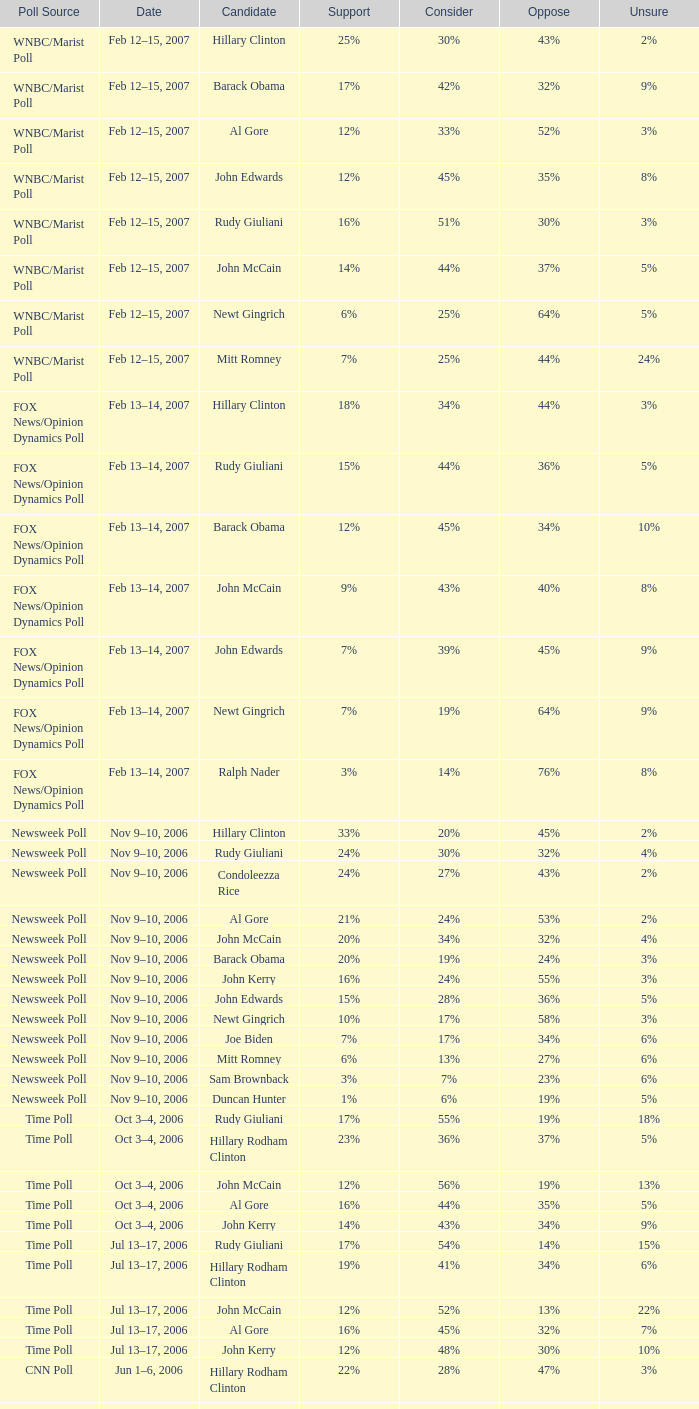What percentage of people said they would consider Rudy Giuliani as a candidate according to the Newsweek poll that showed 32% opposed him? 30%. 